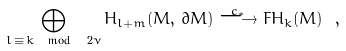Convert formula to latex. <formula><loc_0><loc_0><loc_500><loc_500>\bigoplus _ { l \, \equiv \, k \mod \ 2 \nu } H _ { l + m } ( M , \, \partial M ) \stackrel { c _ { * } } \longrightarrow F H _ { k } ( M ) \ ,</formula> 